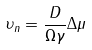Convert formula to latex. <formula><loc_0><loc_0><loc_500><loc_500>\upsilon _ { n } = \frac { D } { \Omega \gamma } \Delta \mu</formula> 